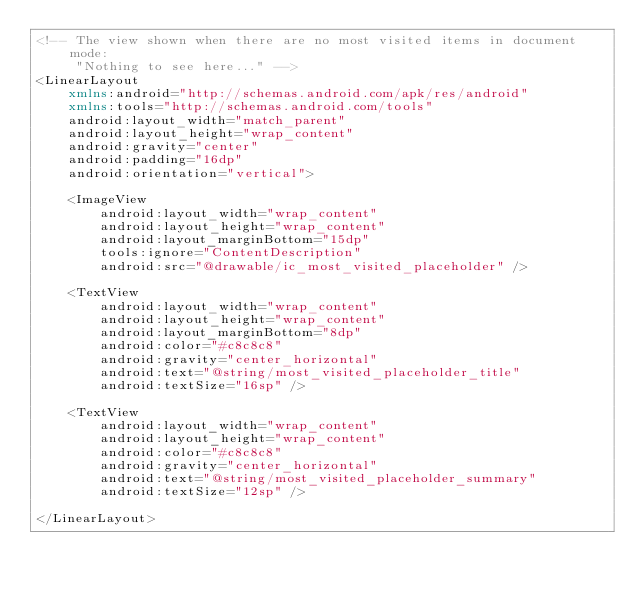<code> <loc_0><loc_0><loc_500><loc_500><_XML_><!-- The view shown when there are no most visited items in document mode:
     "Nothing to see here..." -->
<LinearLayout
    xmlns:android="http://schemas.android.com/apk/res/android"
    xmlns:tools="http://schemas.android.com/tools"
    android:layout_width="match_parent"
    android:layout_height="wrap_content"
    android:gravity="center"
    android:padding="16dp"
    android:orientation="vertical">

    <ImageView
        android:layout_width="wrap_content"
        android:layout_height="wrap_content"
        android:layout_marginBottom="15dp"
        tools:ignore="ContentDescription"
        android:src="@drawable/ic_most_visited_placeholder" />

    <TextView
        android:layout_width="wrap_content"
        android:layout_height="wrap_content"
        android:layout_marginBottom="8dp"
        android:color="#c8c8c8"
        android:gravity="center_horizontal"
        android:text="@string/most_visited_placeholder_title"
        android:textSize="16sp" />

    <TextView
        android:layout_width="wrap_content"
        android:layout_height="wrap_content"
        android:color="#c8c8c8"
        android:gravity="center_horizontal"
        android:text="@string/most_visited_placeholder_summary"
        android:textSize="12sp" />

</LinearLayout></code> 